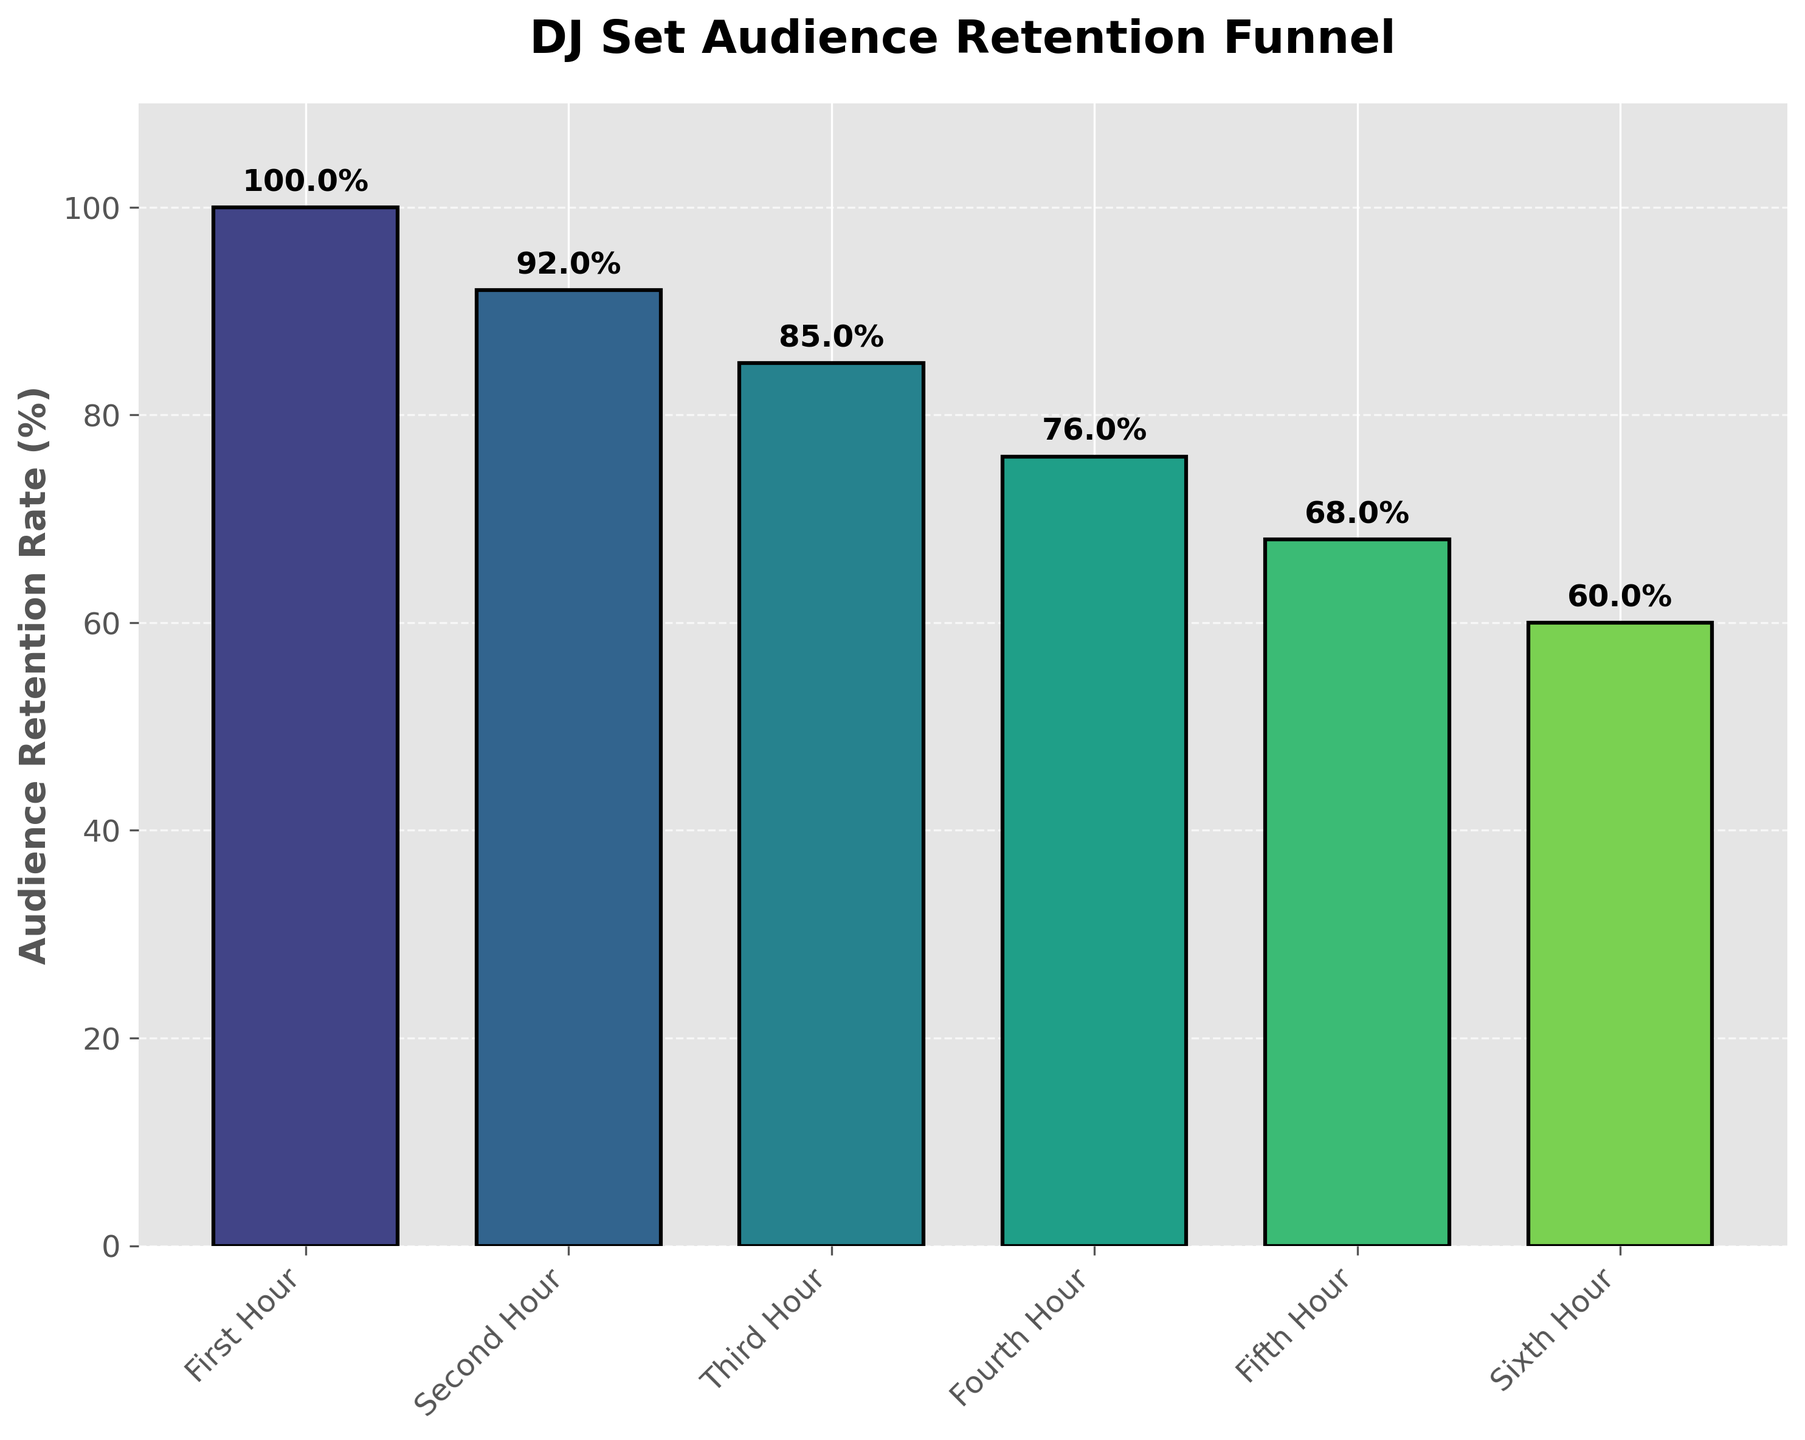What's the title of this figure? The title is located at the top of the figure and it is usually in a larger, bold font to make it stand out.
Answer: DJ Set Audience Retention Funnel What's the audience retention rate during the fourth hour? This can be found on the Y-axis corresponding to the fourth hour, and it is also labeled above the bar.
Answer: 76% How many hours of DJ set is shown in this figure? Count the number of items on the X-axis. Each label corresponds to an hour.
Answer: 6 What is the retention rate difference from the first hour to the sixth hour? Subtract the retention rate of the sixth hour from the retention rate of the first hour: 100% - 60%.
Answer: 40% Which hour has the highest audience retention rate? Look for the bar with the highest value on the Y-axis.
Answer: First Hour How does the second hour's retention rate compare to the fifth hour's retention rate? Compare the values on the Y-axis for the second and fifth hours. Second hour is 92% and fifth hour is 68%. So, the second hour is higher.
Answer: Second Hour is higher What's the average audience retention rate over the six hours? Add up all the percentages and then divide by the number of hours: (100% + 92% + 85% + 76% + 68% + 60%) / 6
Answer: 80.17% What is the median audience retention rate for the hours shown? Arrange the percentages in ascending order: 60%, 68%, 76%, 85%, 92%, 100%. The median is the average of the third and fourth values (76% and 85%). (76 + 85)/2 = 80.5
Answer: 80.5% During which hour is the drop in retention rate the highest? Calculate the difference in retention rates between consecutive hours and find the maximum. The largest drop is from 85% to 76% (Third to Fourth hour), which is 9%.
Answer: Third to Fourth Hour If the trend continued, what would the retention rate be in the seventh hour? Notice the pattern of decline in retention rates. The decline is approximately 8% to 9% per hour. Assuming a similar drop, subtract around 8% from the sixth hour rate (60%): 60% - 8% = 52%
Answer: 52% 